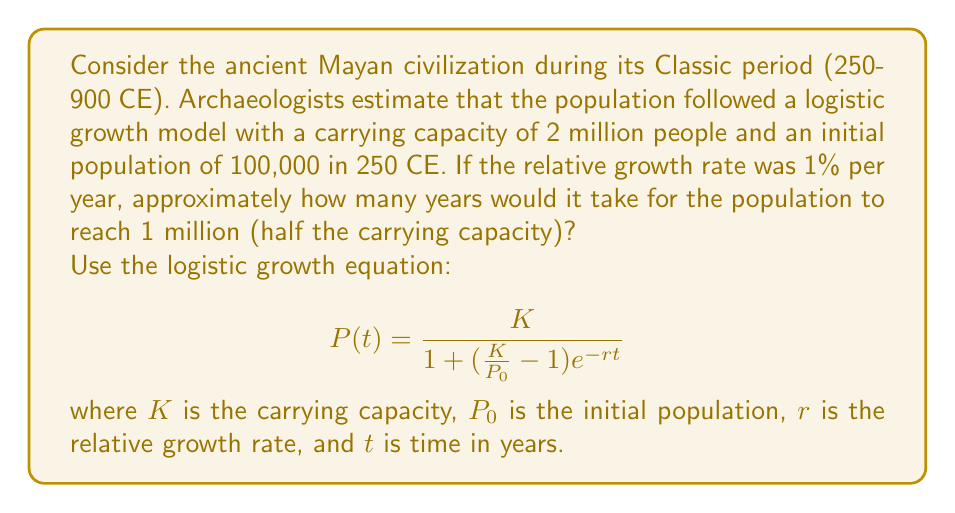Teach me how to tackle this problem. To solve this problem, we'll use the logistic growth equation and the given information:

1. Carrying capacity $K = 2,000,000$
2. Initial population $P_0 = 100,000$
3. Relative growth rate $r = 0.01$ (1% per year)
4. Target population $P(t) = 1,000,000$ (half the carrying capacity)

Let's substitute these values into the equation:

$$ 1,000,000 = \frac{2,000,000}{1 + (\frac{2,000,000}{100,000} - 1)e^{-0.01t}} $$

Simplify:
$$ 1,000,000 = \frac{2,000,000}{1 + 19e^{-0.01t}} $$

Divide both sides by 1,000,000:
$$ 1 = \frac{2}{1 + 19e^{-0.01t}} $$

Multiply both sides by $(1 + 19e^{-0.01t})$:
$$ 1 + 19e^{-0.01t} = 2 $$

Subtract 1 from both sides:
$$ 19e^{-0.01t} = 1 $$

Divide both sides by 19:
$$ e^{-0.01t} = \frac{1}{19} $$

Take the natural logarithm of both sides:
$$ -0.01t = \ln(\frac{1}{19}) $$

Divide both sides by -0.01:
$$ t = -100 \ln(\frac{1}{19}) $$

Calculate the result:
$$ t \approx 295.85 $$

Round to the nearest year:
$$ t \approx 296 \text{ years} $$

Therefore, it would take approximately 296 years for the Mayan population to reach 1 million people, which would be around 546 CE.
Answer: 296 years 